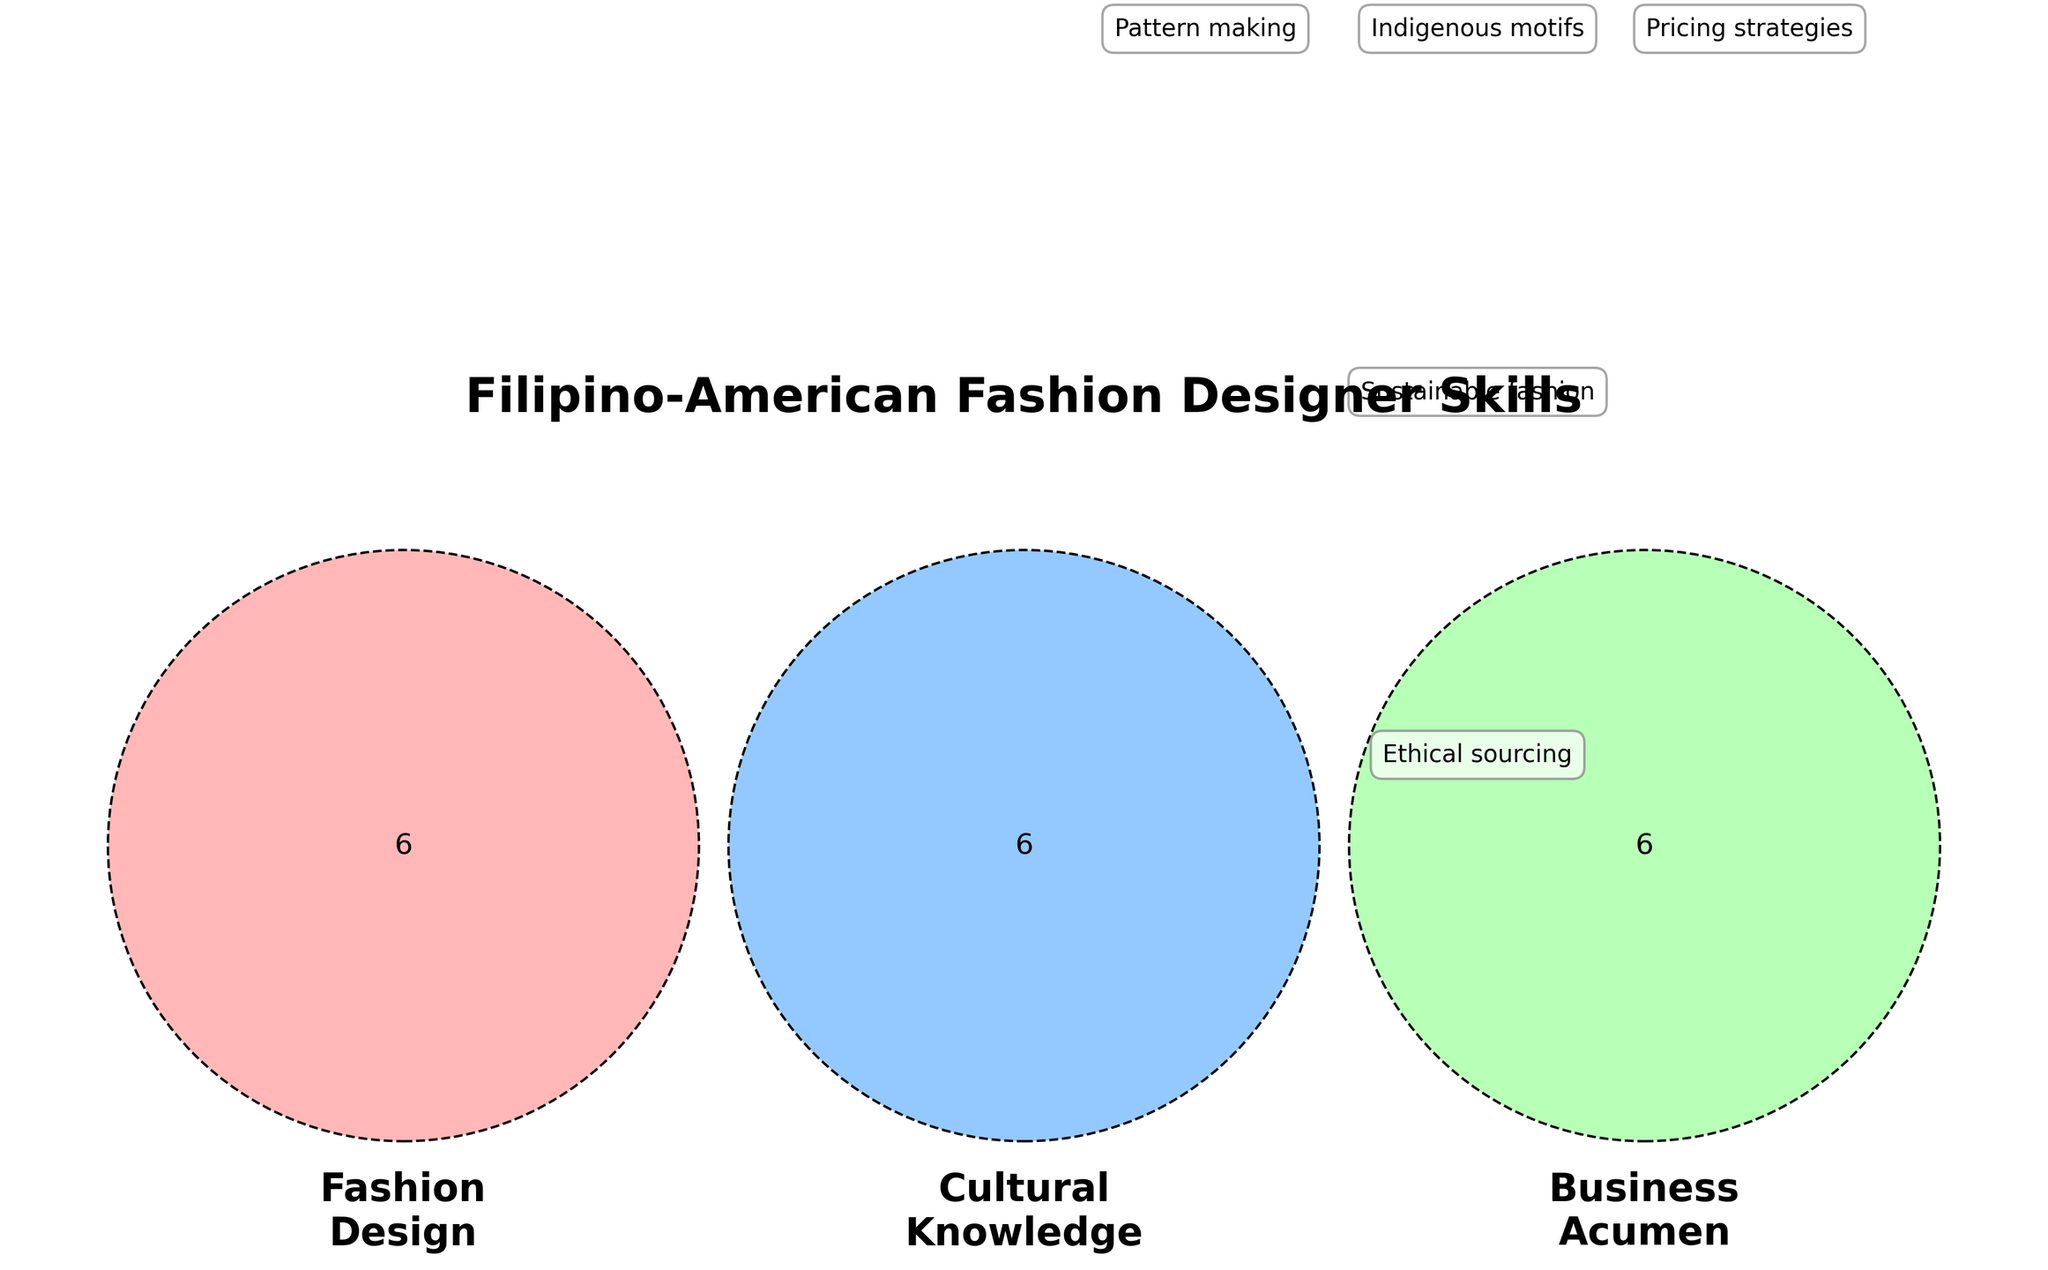What are the three main categories displayed in the Venn Diagram? The Venn Diagram shows intersecting circles labeled "Fashion Design", "Cultural Knowledge", and "Business Acumen", indicating the three main categories.
Answer: Fashion Design, Cultural Knowledge, Business Acumen Which skill overlaps between Fashion Design and Cultural Knowledge, but not with Business Acumen? By looking at the intersecting area between Fashion Design and Cultural Knowledge but outside Business Acumen, we can identify "Indigenous motifs".
Answer: Indigenous motifs How many skills are unique to the Business Acumen category? By examining the circle representing Business Acumen excluding intersections with the other two categories, we see three skills: Pricing strategies, Negotiation skills, and Budgeting.
Answer: Three Name a skill that is shared among Fashion Design, Cultural Knowledge, and Business Acumen. The central area where all three circles intersect represents the shared skills. The Venn Diagram shows one skill in this area: "Ethical sourcing".
Answer: Ethical sourcing Which skill can be found at the intersection of Cultural Knowledge and Business Acumen? The overlapping region between Cultural Knowledge and Business Acumen but outside Fashion Design shows "Supply chain management".
Answer: Supply chain management What is a skill only associated with Fashion Design? To find a skill exclusive to Fashion Design, check the part of the circle that does not intersect with the others. One of these is "Pattern making".
Answer: Pattern making How many total skills are presented across all categories in the Venn Diagram? Count each skill listed in all areas of the Venn Diagram including overlaps: 20 unique skills shown.
Answer: 20 Which skills link Fashion Design and Business Acumen but exclude Cultural Knowledge? The overlapping region between Fashion Design and Business Acumen, excluding Cultural Knowledge, shows "Sustainable fashion".
Answer: Sustainable fashion List two fundamental skills shared between Fashion Design and Cultural Knowledge. Check the overlapping area of these two circles but not with Business Acumen to find "Color theory" and "Regional weaving techniques".
Answer: Color theory, Regional weaving techniques 